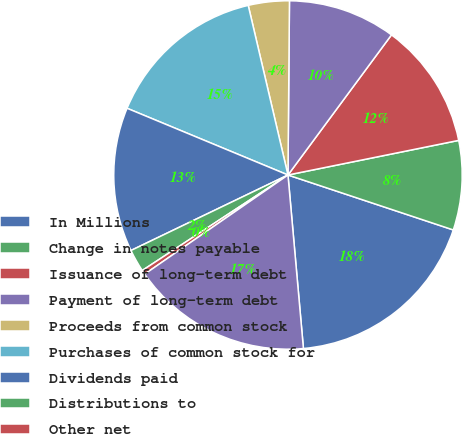<chart> <loc_0><loc_0><loc_500><loc_500><pie_chart><fcel>In Millions<fcel>Change in notes payable<fcel>Issuance of long-term debt<fcel>Payment of long-term debt<fcel>Proceeds from common stock<fcel>Purchases of common stock for<fcel>Dividends paid<fcel>Distributions to<fcel>Other net<fcel>Net cash provided (used) by<nl><fcel>18.48%<fcel>8.29%<fcel>11.69%<fcel>9.99%<fcel>3.8%<fcel>15.08%<fcel>13.39%<fcel>2.1%<fcel>0.4%<fcel>16.78%<nl></chart> 